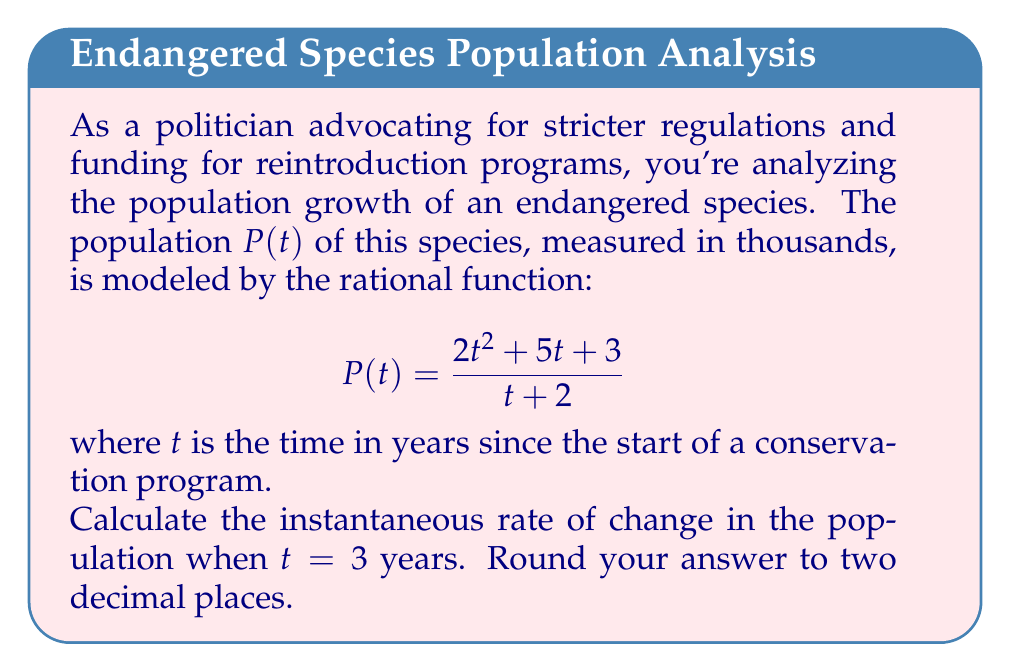Provide a solution to this math problem. To find the instantaneous rate of change, we need to calculate the derivative of the population function $P(t)$ and evaluate it at $t = 3$. Let's proceed step-by-step:

1) First, we need to find $P'(t)$ using the quotient rule. If $P(t) = \frac{u}{v}$, then $P'(t) = \frac{u'v - uv'}{v^2}$.

   Here, $u = 2t^2 + 5t + 3$ and $v = t + 2$

2) Calculate $u'$ and $v'$:
   $u' = 4t + 5$
   $v' = 1$

3) Apply the quotient rule:

   $$P'(t) = \frac{(4t + 5)(t + 2) - (2t^2 + 5t + 3)(1)}{(t + 2)^2}$$

4) Simplify the numerator:
   
   $$P'(t) = \frac{4t^2 + 8t + 5t + 10 - 2t^2 - 5t - 3}{(t + 2)^2}$$
   $$P'(t) = \frac{2t^2 + 8t + 7}{(t + 2)^2}$$

5) Now, evaluate $P'(3)$:

   $$P'(3) = \frac{2(3)^2 + 8(3) + 7}{(3 + 2)^2} = \frac{18 + 24 + 7}{25} = \frac{49}{25} = 1.96$$

Therefore, the instantaneous rate of change when $t = 3$ is approximately 1.96 thousand per year.
Answer: 1.96 thousand per year 